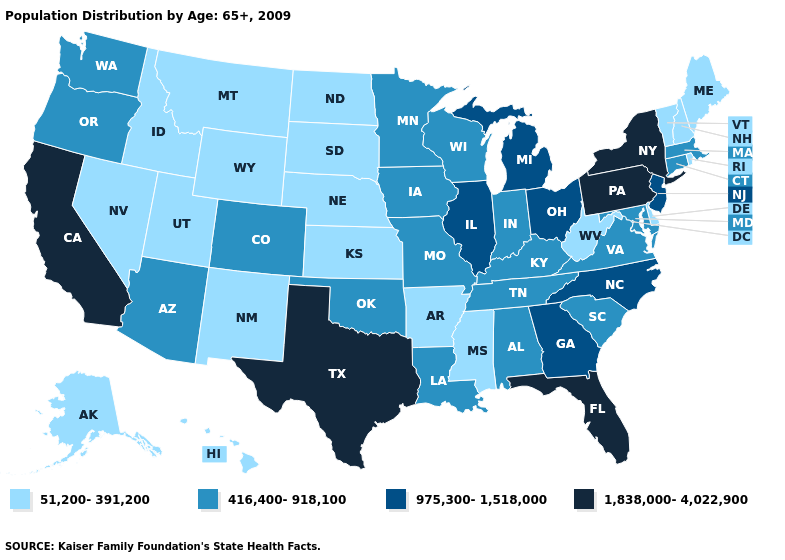Does Pennsylvania have the lowest value in the Northeast?
Be succinct. No. What is the value of Nebraska?
Quick response, please. 51,200-391,200. Does Michigan have the highest value in the USA?
Give a very brief answer. No. Among the states that border Oklahoma , which have the highest value?
Short answer required. Texas. Among the states that border Arkansas , does Oklahoma have the lowest value?
Answer briefly. No. Among the states that border Texas , does Arkansas have the lowest value?
Quick response, please. Yes. How many symbols are there in the legend?
Answer briefly. 4. Name the states that have a value in the range 51,200-391,200?
Short answer required. Alaska, Arkansas, Delaware, Hawaii, Idaho, Kansas, Maine, Mississippi, Montana, Nebraska, Nevada, New Hampshire, New Mexico, North Dakota, Rhode Island, South Dakota, Utah, Vermont, West Virginia, Wyoming. Name the states that have a value in the range 975,300-1,518,000?
Answer briefly. Georgia, Illinois, Michigan, New Jersey, North Carolina, Ohio. Name the states that have a value in the range 51,200-391,200?
Concise answer only. Alaska, Arkansas, Delaware, Hawaii, Idaho, Kansas, Maine, Mississippi, Montana, Nebraska, Nevada, New Hampshire, New Mexico, North Dakota, Rhode Island, South Dakota, Utah, Vermont, West Virginia, Wyoming. What is the value of Massachusetts?
Concise answer only. 416,400-918,100. Which states hav the highest value in the West?
Keep it brief. California. Is the legend a continuous bar?
Short answer required. No. 